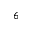<formula> <loc_0><loc_0><loc_500><loc_500>_ { 6 }</formula> 